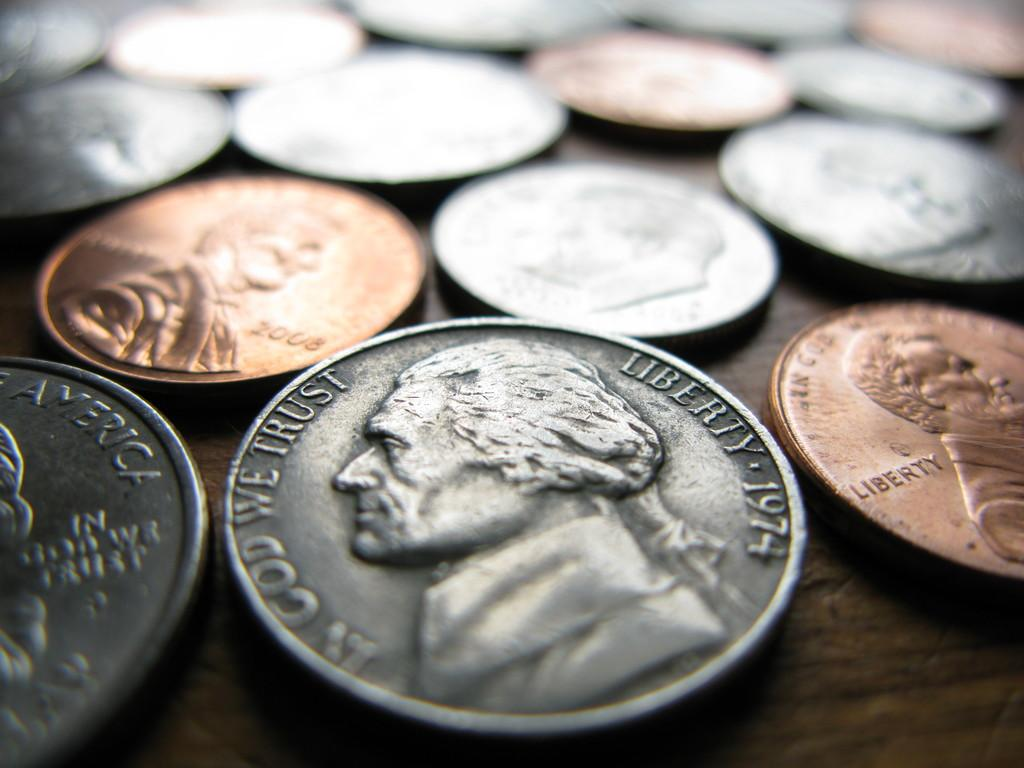<image>
Summarize the visual content of the image. A number of coins sits on a table, with the one most in the foreground dated 1974. 